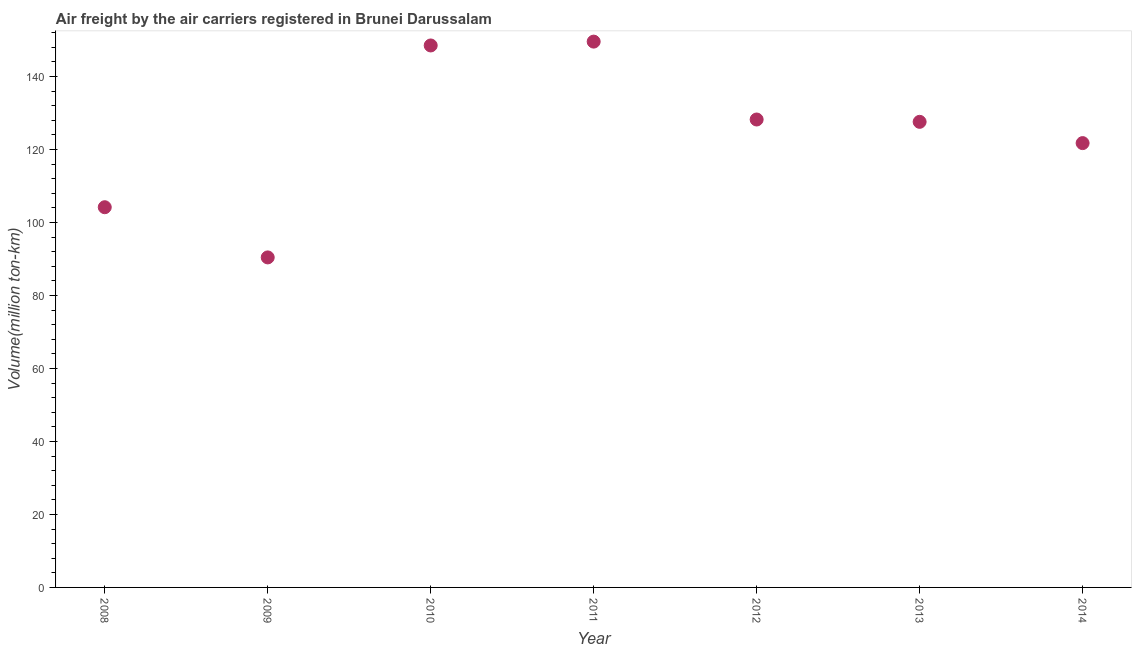What is the air freight in 2011?
Provide a succinct answer. 149.58. Across all years, what is the maximum air freight?
Your response must be concise. 149.58. Across all years, what is the minimum air freight?
Keep it short and to the point. 90.44. In which year was the air freight maximum?
Provide a succinct answer. 2011. In which year was the air freight minimum?
Your answer should be compact. 2009. What is the sum of the air freight?
Offer a very short reply. 870.33. What is the difference between the air freight in 2009 and 2010?
Ensure brevity in your answer.  -58.08. What is the average air freight per year?
Ensure brevity in your answer.  124.33. What is the median air freight?
Keep it short and to the point. 127.59. In how many years, is the air freight greater than 116 million ton-km?
Provide a succinct answer. 5. What is the ratio of the air freight in 2010 to that in 2011?
Give a very brief answer. 0.99. Is the difference between the air freight in 2009 and 2014 greater than the difference between any two years?
Make the answer very short. No. What is the difference between the highest and the second highest air freight?
Make the answer very short. 1.06. Is the sum of the air freight in 2012 and 2013 greater than the maximum air freight across all years?
Give a very brief answer. Yes. What is the difference between the highest and the lowest air freight?
Your answer should be compact. 59.14. Does the air freight monotonically increase over the years?
Offer a very short reply. No. What is the title of the graph?
Provide a short and direct response. Air freight by the air carriers registered in Brunei Darussalam. What is the label or title of the X-axis?
Your answer should be very brief. Year. What is the label or title of the Y-axis?
Offer a very short reply. Volume(million ton-km). What is the Volume(million ton-km) in 2008?
Offer a very short reply. 104.19. What is the Volume(million ton-km) in 2009?
Offer a terse response. 90.44. What is the Volume(million ton-km) in 2010?
Offer a terse response. 148.52. What is the Volume(million ton-km) in 2011?
Provide a succinct answer. 149.58. What is the Volume(million ton-km) in 2012?
Make the answer very short. 128.23. What is the Volume(million ton-km) in 2013?
Your response must be concise. 127.59. What is the Volume(million ton-km) in 2014?
Provide a short and direct response. 121.76. What is the difference between the Volume(million ton-km) in 2008 and 2009?
Offer a terse response. 13.75. What is the difference between the Volume(million ton-km) in 2008 and 2010?
Make the answer very short. -44.33. What is the difference between the Volume(million ton-km) in 2008 and 2011?
Keep it short and to the point. -45.38. What is the difference between the Volume(million ton-km) in 2008 and 2012?
Provide a succinct answer. -24.04. What is the difference between the Volume(million ton-km) in 2008 and 2013?
Provide a short and direct response. -23.4. What is the difference between the Volume(million ton-km) in 2008 and 2014?
Make the answer very short. -17.57. What is the difference between the Volume(million ton-km) in 2009 and 2010?
Keep it short and to the point. -58.08. What is the difference between the Volume(million ton-km) in 2009 and 2011?
Keep it short and to the point. -59.14. What is the difference between the Volume(million ton-km) in 2009 and 2012?
Provide a succinct answer. -37.79. What is the difference between the Volume(million ton-km) in 2009 and 2013?
Your answer should be compact. -37.15. What is the difference between the Volume(million ton-km) in 2009 and 2014?
Provide a succinct answer. -31.32. What is the difference between the Volume(million ton-km) in 2010 and 2011?
Provide a succinct answer. -1.05. What is the difference between the Volume(million ton-km) in 2010 and 2012?
Provide a short and direct response. 20.29. What is the difference between the Volume(million ton-km) in 2010 and 2013?
Provide a short and direct response. 20.93. What is the difference between the Volume(million ton-km) in 2010 and 2014?
Your response must be concise. 26.76. What is the difference between the Volume(million ton-km) in 2011 and 2012?
Your answer should be very brief. 21.34. What is the difference between the Volume(million ton-km) in 2011 and 2013?
Provide a succinct answer. 21.98. What is the difference between the Volume(million ton-km) in 2011 and 2014?
Keep it short and to the point. 27.81. What is the difference between the Volume(million ton-km) in 2012 and 2013?
Make the answer very short. 0.64. What is the difference between the Volume(million ton-km) in 2012 and 2014?
Give a very brief answer. 6.47. What is the difference between the Volume(million ton-km) in 2013 and 2014?
Make the answer very short. 5.83. What is the ratio of the Volume(million ton-km) in 2008 to that in 2009?
Ensure brevity in your answer.  1.15. What is the ratio of the Volume(million ton-km) in 2008 to that in 2010?
Your answer should be very brief. 0.7. What is the ratio of the Volume(million ton-km) in 2008 to that in 2011?
Keep it short and to the point. 0.7. What is the ratio of the Volume(million ton-km) in 2008 to that in 2012?
Provide a succinct answer. 0.81. What is the ratio of the Volume(million ton-km) in 2008 to that in 2013?
Provide a succinct answer. 0.82. What is the ratio of the Volume(million ton-km) in 2008 to that in 2014?
Your answer should be very brief. 0.86. What is the ratio of the Volume(million ton-km) in 2009 to that in 2010?
Provide a succinct answer. 0.61. What is the ratio of the Volume(million ton-km) in 2009 to that in 2011?
Offer a very short reply. 0.6. What is the ratio of the Volume(million ton-km) in 2009 to that in 2012?
Ensure brevity in your answer.  0.7. What is the ratio of the Volume(million ton-km) in 2009 to that in 2013?
Keep it short and to the point. 0.71. What is the ratio of the Volume(million ton-km) in 2009 to that in 2014?
Make the answer very short. 0.74. What is the ratio of the Volume(million ton-km) in 2010 to that in 2012?
Your answer should be very brief. 1.16. What is the ratio of the Volume(million ton-km) in 2010 to that in 2013?
Keep it short and to the point. 1.16. What is the ratio of the Volume(million ton-km) in 2010 to that in 2014?
Give a very brief answer. 1.22. What is the ratio of the Volume(million ton-km) in 2011 to that in 2012?
Make the answer very short. 1.17. What is the ratio of the Volume(million ton-km) in 2011 to that in 2013?
Give a very brief answer. 1.17. What is the ratio of the Volume(million ton-km) in 2011 to that in 2014?
Make the answer very short. 1.23. What is the ratio of the Volume(million ton-km) in 2012 to that in 2014?
Make the answer very short. 1.05. What is the ratio of the Volume(million ton-km) in 2013 to that in 2014?
Your answer should be very brief. 1.05. 